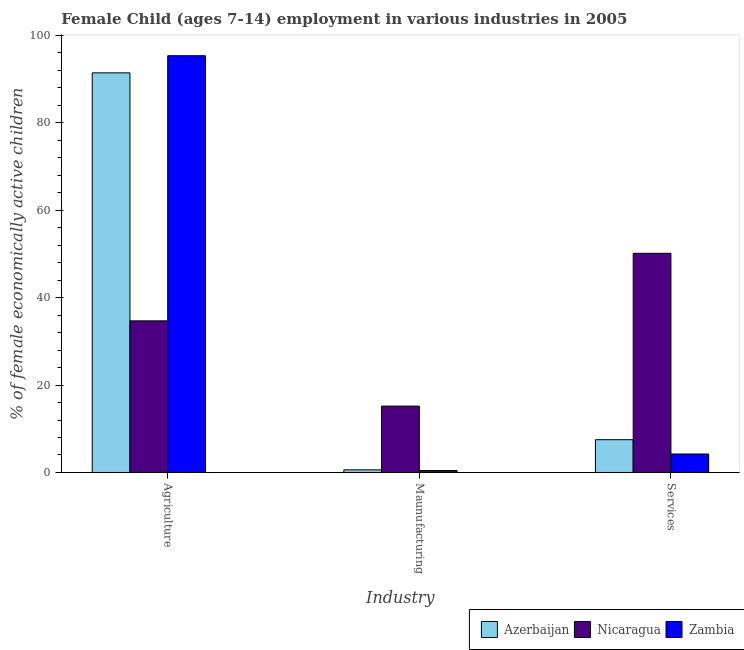Are the number of bars on each tick of the X-axis equal?
Your answer should be very brief. Yes. How many bars are there on the 1st tick from the left?
Your answer should be very brief. 3. What is the label of the 1st group of bars from the left?
Your answer should be very brief. Agriculture. What is the percentage of economically active children in manufacturing in Nicaragua?
Your answer should be compact. 15.18. Across all countries, what is the maximum percentage of economically active children in agriculture?
Provide a succinct answer. 95.32. Across all countries, what is the minimum percentage of economically active children in agriculture?
Your answer should be compact. 34.68. In which country was the percentage of economically active children in services maximum?
Provide a short and direct response. Nicaragua. In which country was the percentage of economically active children in services minimum?
Your answer should be compact. Zambia. What is the total percentage of economically active children in manufacturing in the graph?
Give a very brief answer. 16.23. What is the difference between the percentage of economically active children in manufacturing in Azerbaijan and that in Zambia?
Your answer should be compact. 0.15. What is the difference between the percentage of economically active children in agriculture in Zambia and the percentage of economically active children in manufacturing in Azerbaijan?
Provide a short and direct response. 94.72. What is the average percentage of economically active children in manufacturing per country?
Offer a very short reply. 5.41. What is the difference between the percentage of economically active children in manufacturing and percentage of economically active children in agriculture in Nicaragua?
Your response must be concise. -19.5. In how many countries, is the percentage of economically active children in agriculture greater than 96 %?
Your answer should be very brief. 0. What is the ratio of the percentage of economically active children in agriculture in Zambia to that in Azerbaijan?
Offer a terse response. 1.04. What is the difference between the highest and the second highest percentage of economically active children in manufacturing?
Your answer should be compact. 14.58. What is the difference between the highest and the lowest percentage of economically active children in manufacturing?
Offer a terse response. 14.73. In how many countries, is the percentage of economically active children in services greater than the average percentage of economically active children in services taken over all countries?
Offer a terse response. 1. What does the 2nd bar from the left in Maunufacturing represents?
Offer a terse response. Nicaragua. What does the 1st bar from the right in Maunufacturing represents?
Make the answer very short. Zambia. How many bars are there?
Your response must be concise. 9. Are all the bars in the graph horizontal?
Offer a very short reply. No. What is the difference between two consecutive major ticks on the Y-axis?
Give a very brief answer. 20. Where does the legend appear in the graph?
Give a very brief answer. Bottom right. How are the legend labels stacked?
Provide a short and direct response. Horizontal. What is the title of the graph?
Make the answer very short. Female Child (ages 7-14) employment in various industries in 2005. Does "Other small states" appear as one of the legend labels in the graph?
Offer a terse response. No. What is the label or title of the X-axis?
Your response must be concise. Industry. What is the label or title of the Y-axis?
Offer a very short reply. % of female economically active children. What is the % of female economically active children in Azerbaijan in Agriculture?
Ensure brevity in your answer.  91.4. What is the % of female economically active children in Nicaragua in Agriculture?
Offer a very short reply. 34.68. What is the % of female economically active children in Zambia in Agriculture?
Offer a very short reply. 95.32. What is the % of female economically active children in Nicaragua in Maunufacturing?
Offer a very short reply. 15.18. What is the % of female economically active children of Zambia in Maunufacturing?
Provide a succinct answer. 0.45. What is the % of female economically active children in Azerbaijan in Services?
Provide a succinct answer. 7.5. What is the % of female economically active children of Nicaragua in Services?
Give a very brief answer. 50.13. What is the % of female economically active children in Zambia in Services?
Make the answer very short. 4.23. Across all Industry, what is the maximum % of female economically active children in Azerbaijan?
Your response must be concise. 91.4. Across all Industry, what is the maximum % of female economically active children of Nicaragua?
Ensure brevity in your answer.  50.13. Across all Industry, what is the maximum % of female economically active children in Zambia?
Offer a very short reply. 95.32. Across all Industry, what is the minimum % of female economically active children in Azerbaijan?
Offer a very short reply. 0.6. Across all Industry, what is the minimum % of female economically active children of Nicaragua?
Provide a succinct answer. 15.18. Across all Industry, what is the minimum % of female economically active children in Zambia?
Provide a succinct answer. 0.45. What is the total % of female economically active children in Azerbaijan in the graph?
Offer a terse response. 99.5. What is the total % of female economically active children of Nicaragua in the graph?
Your answer should be very brief. 99.99. What is the difference between the % of female economically active children in Azerbaijan in Agriculture and that in Maunufacturing?
Provide a succinct answer. 90.8. What is the difference between the % of female economically active children in Zambia in Agriculture and that in Maunufacturing?
Your answer should be compact. 94.87. What is the difference between the % of female economically active children in Azerbaijan in Agriculture and that in Services?
Your answer should be compact. 83.9. What is the difference between the % of female economically active children of Nicaragua in Agriculture and that in Services?
Provide a short and direct response. -15.45. What is the difference between the % of female economically active children of Zambia in Agriculture and that in Services?
Make the answer very short. 91.09. What is the difference between the % of female economically active children in Nicaragua in Maunufacturing and that in Services?
Keep it short and to the point. -34.95. What is the difference between the % of female economically active children of Zambia in Maunufacturing and that in Services?
Your answer should be very brief. -3.78. What is the difference between the % of female economically active children of Azerbaijan in Agriculture and the % of female economically active children of Nicaragua in Maunufacturing?
Offer a terse response. 76.22. What is the difference between the % of female economically active children in Azerbaijan in Agriculture and the % of female economically active children in Zambia in Maunufacturing?
Make the answer very short. 90.95. What is the difference between the % of female economically active children of Nicaragua in Agriculture and the % of female economically active children of Zambia in Maunufacturing?
Provide a succinct answer. 34.23. What is the difference between the % of female economically active children in Azerbaijan in Agriculture and the % of female economically active children in Nicaragua in Services?
Your answer should be very brief. 41.27. What is the difference between the % of female economically active children in Azerbaijan in Agriculture and the % of female economically active children in Zambia in Services?
Ensure brevity in your answer.  87.17. What is the difference between the % of female economically active children in Nicaragua in Agriculture and the % of female economically active children in Zambia in Services?
Keep it short and to the point. 30.45. What is the difference between the % of female economically active children in Azerbaijan in Maunufacturing and the % of female economically active children in Nicaragua in Services?
Ensure brevity in your answer.  -49.53. What is the difference between the % of female economically active children of Azerbaijan in Maunufacturing and the % of female economically active children of Zambia in Services?
Make the answer very short. -3.63. What is the difference between the % of female economically active children of Nicaragua in Maunufacturing and the % of female economically active children of Zambia in Services?
Offer a terse response. 10.95. What is the average % of female economically active children of Azerbaijan per Industry?
Ensure brevity in your answer.  33.17. What is the average % of female economically active children in Nicaragua per Industry?
Provide a succinct answer. 33.33. What is the average % of female economically active children in Zambia per Industry?
Offer a very short reply. 33.33. What is the difference between the % of female economically active children in Azerbaijan and % of female economically active children in Nicaragua in Agriculture?
Offer a terse response. 56.72. What is the difference between the % of female economically active children of Azerbaijan and % of female economically active children of Zambia in Agriculture?
Ensure brevity in your answer.  -3.92. What is the difference between the % of female economically active children of Nicaragua and % of female economically active children of Zambia in Agriculture?
Your answer should be very brief. -60.64. What is the difference between the % of female economically active children of Azerbaijan and % of female economically active children of Nicaragua in Maunufacturing?
Provide a succinct answer. -14.58. What is the difference between the % of female economically active children of Azerbaijan and % of female economically active children of Zambia in Maunufacturing?
Provide a succinct answer. 0.15. What is the difference between the % of female economically active children of Nicaragua and % of female economically active children of Zambia in Maunufacturing?
Provide a succinct answer. 14.73. What is the difference between the % of female economically active children of Azerbaijan and % of female economically active children of Nicaragua in Services?
Make the answer very short. -42.63. What is the difference between the % of female economically active children of Azerbaijan and % of female economically active children of Zambia in Services?
Ensure brevity in your answer.  3.27. What is the difference between the % of female economically active children in Nicaragua and % of female economically active children in Zambia in Services?
Your answer should be very brief. 45.9. What is the ratio of the % of female economically active children of Azerbaijan in Agriculture to that in Maunufacturing?
Offer a very short reply. 152.33. What is the ratio of the % of female economically active children of Nicaragua in Agriculture to that in Maunufacturing?
Provide a succinct answer. 2.28. What is the ratio of the % of female economically active children of Zambia in Agriculture to that in Maunufacturing?
Your response must be concise. 211.82. What is the ratio of the % of female economically active children in Azerbaijan in Agriculture to that in Services?
Make the answer very short. 12.19. What is the ratio of the % of female economically active children of Nicaragua in Agriculture to that in Services?
Offer a very short reply. 0.69. What is the ratio of the % of female economically active children in Zambia in Agriculture to that in Services?
Keep it short and to the point. 22.53. What is the ratio of the % of female economically active children in Nicaragua in Maunufacturing to that in Services?
Your answer should be compact. 0.3. What is the ratio of the % of female economically active children of Zambia in Maunufacturing to that in Services?
Your response must be concise. 0.11. What is the difference between the highest and the second highest % of female economically active children in Azerbaijan?
Ensure brevity in your answer.  83.9. What is the difference between the highest and the second highest % of female economically active children of Nicaragua?
Offer a terse response. 15.45. What is the difference between the highest and the second highest % of female economically active children in Zambia?
Provide a short and direct response. 91.09. What is the difference between the highest and the lowest % of female economically active children in Azerbaijan?
Your answer should be compact. 90.8. What is the difference between the highest and the lowest % of female economically active children of Nicaragua?
Give a very brief answer. 34.95. What is the difference between the highest and the lowest % of female economically active children of Zambia?
Ensure brevity in your answer.  94.87. 